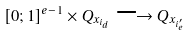Convert formula to latex. <formula><loc_0><loc_0><loc_500><loc_500>[ 0 ; 1 ] ^ { e - 1 } \times Q _ { x _ { i _ { d } } } \longrightarrow Q _ { x _ { i ^ { \prime } _ { e } } }</formula> 